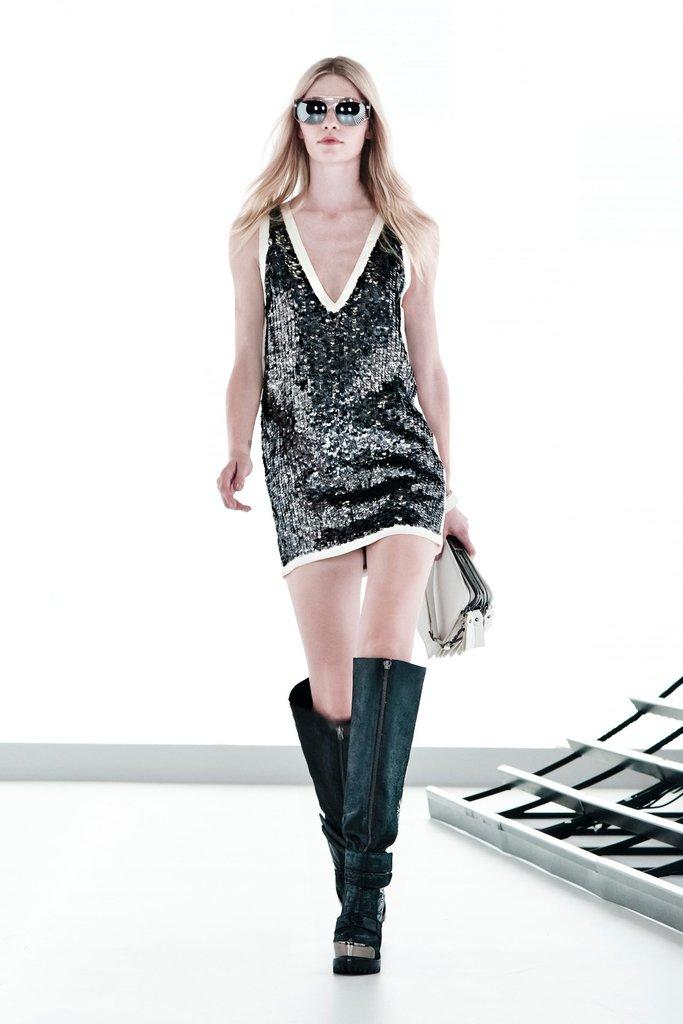What can be seen in the image? There is a person in the image. What is the person wearing? The person is wearing a white and black color dress. What accessory is the person wearing? The person is wearing goggles. What object is the person holding? The person is holding a wallet. What color is the wall in the background of the image? The wall in the background of the image is white. What type of business does the farmer run in the image? There is no farmer or business present in the image; it features a person wearing goggles and holding a wallet. How many boats are visible in the image? There are no boats present in the image. 